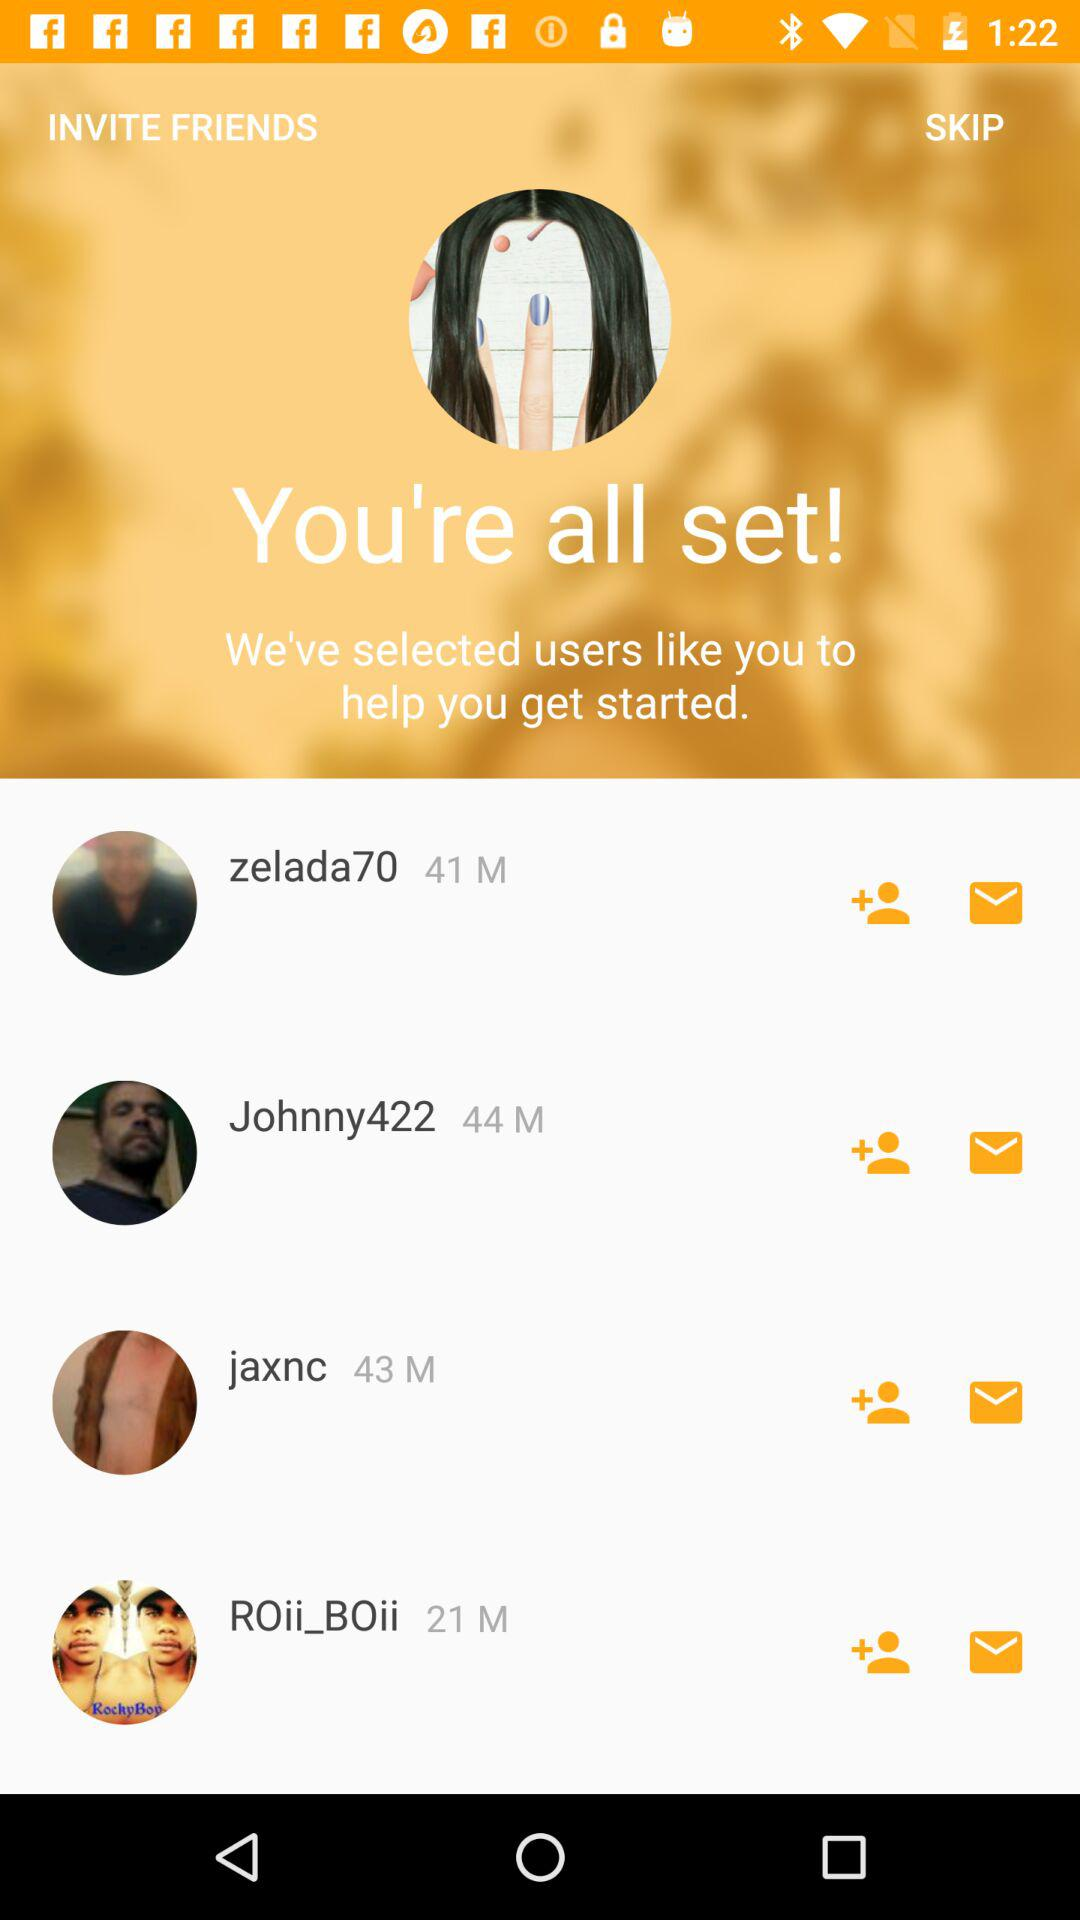21 is what person's age? The person is "ROii_BOii". 